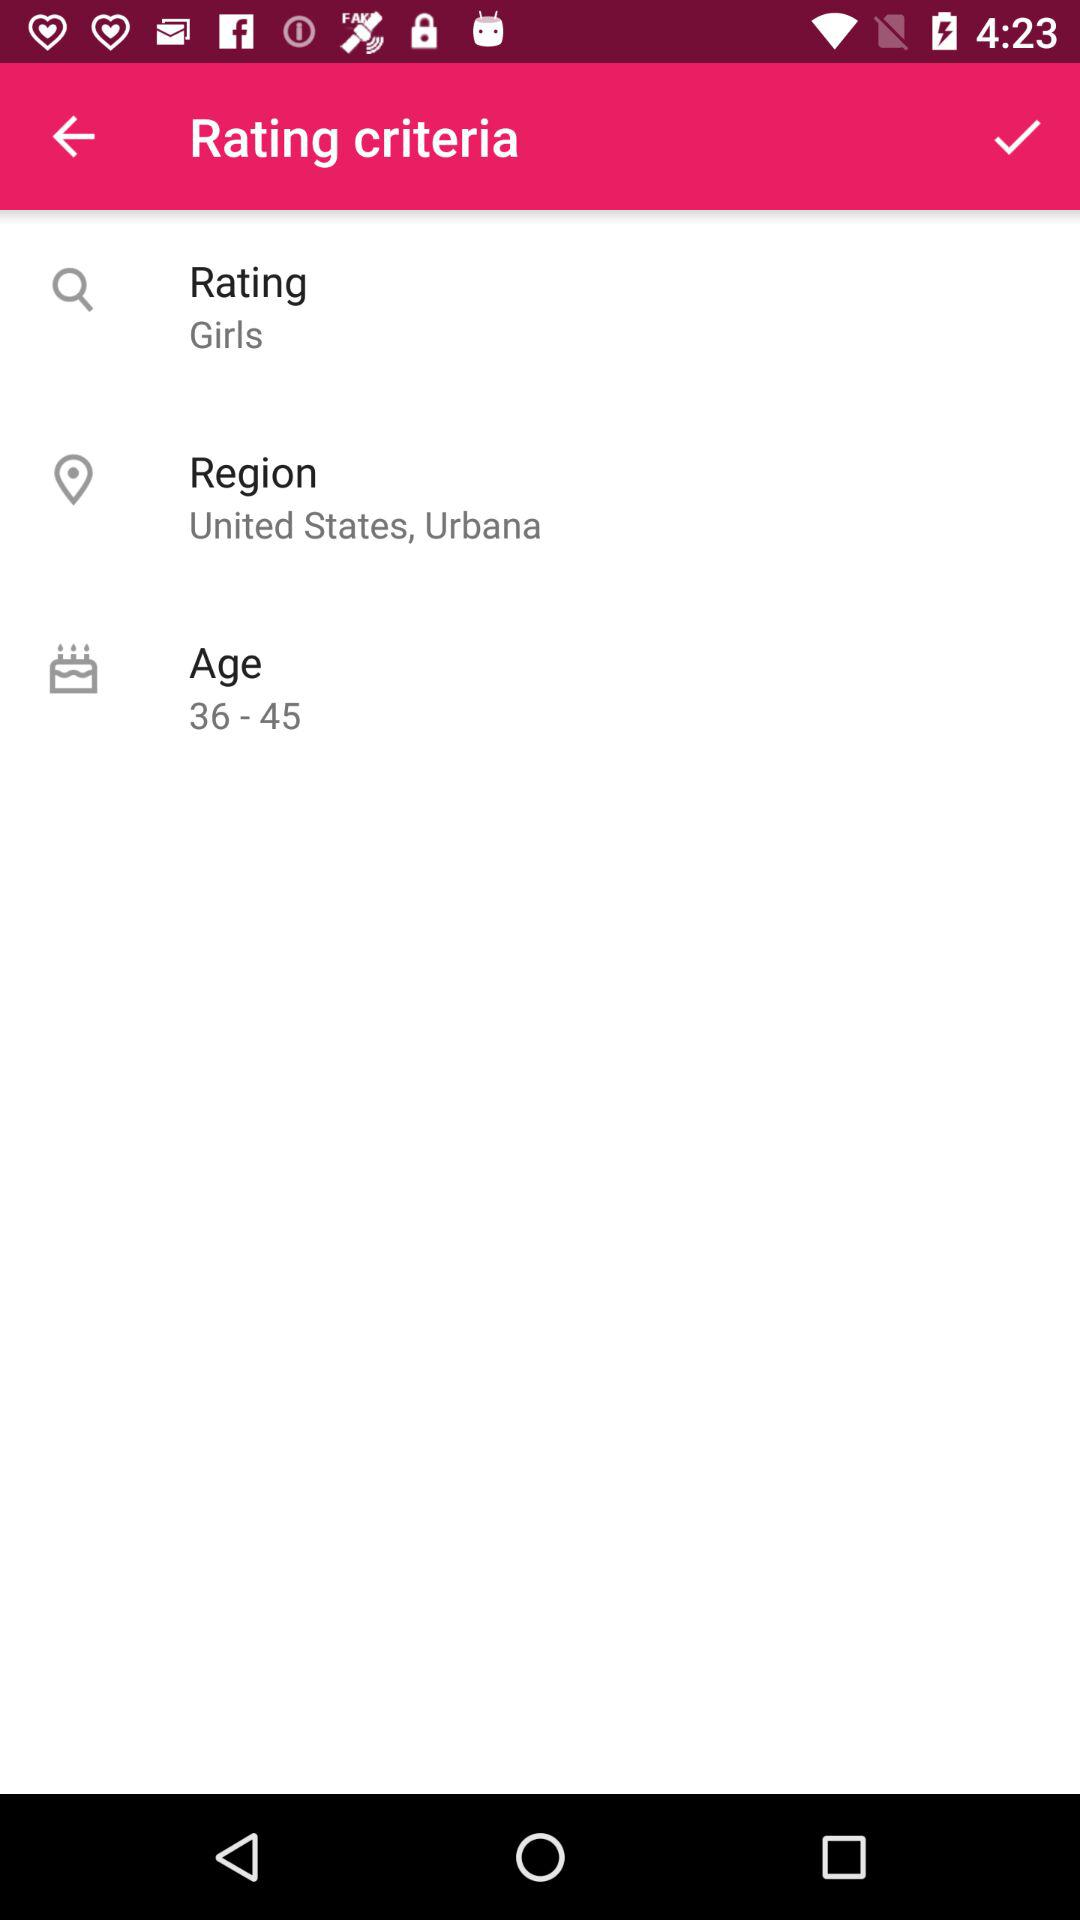Which gender has been chosen in "Rating criteria"? The gender that has been chosen in "Rating criteria" is "Girls". 